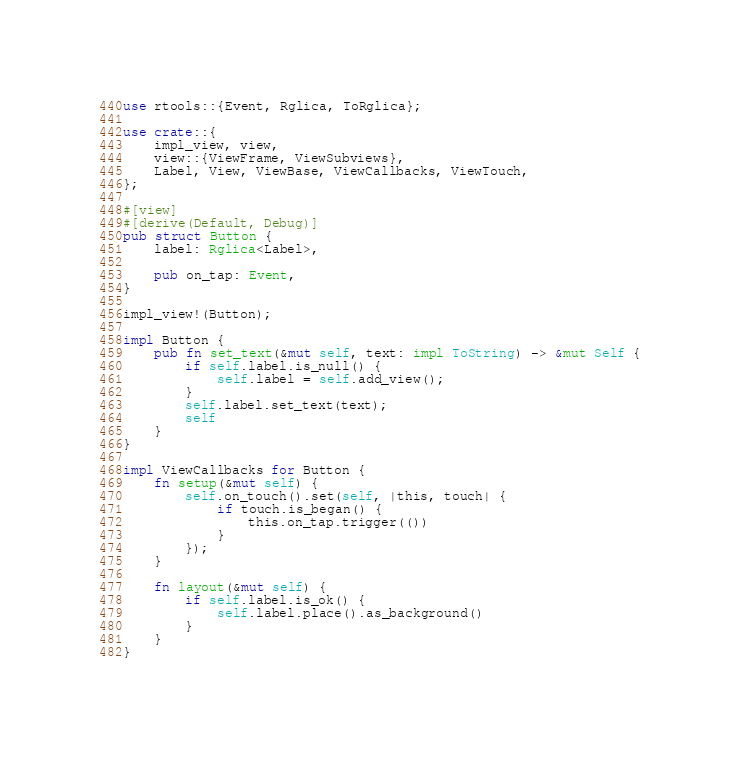<code> <loc_0><loc_0><loc_500><loc_500><_Rust_>use rtools::{Event, Rglica, ToRglica};

use crate::{
    impl_view, view,
    view::{ViewFrame, ViewSubviews},
    Label, View, ViewBase, ViewCallbacks, ViewTouch,
};

#[view]
#[derive(Default, Debug)]
pub struct Button {
    label: Rglica<Label>,

    pub on_tap: Event,
}

impl_view!(Button);

impl Button {
    pub fn set_text(&mut self, text: impl ToString) -> &mut Self {
        if self.label.is_null() {
            self.label = self.add_view();
        }
        self.label.set_text(text);
        self
    }
}

impl ViewCallbacks for Button {
    fn setup(&mut self) {
        self.on_touch().set(self, |this, touch| {
            if touch.is_began() {
                this.on_tap.trigger(())
            }
        });
    }

    fn layout(&mut self) {
        if self.label.is_ok() {
            self.label.place().as_background()
        }
    }
}
</code> 